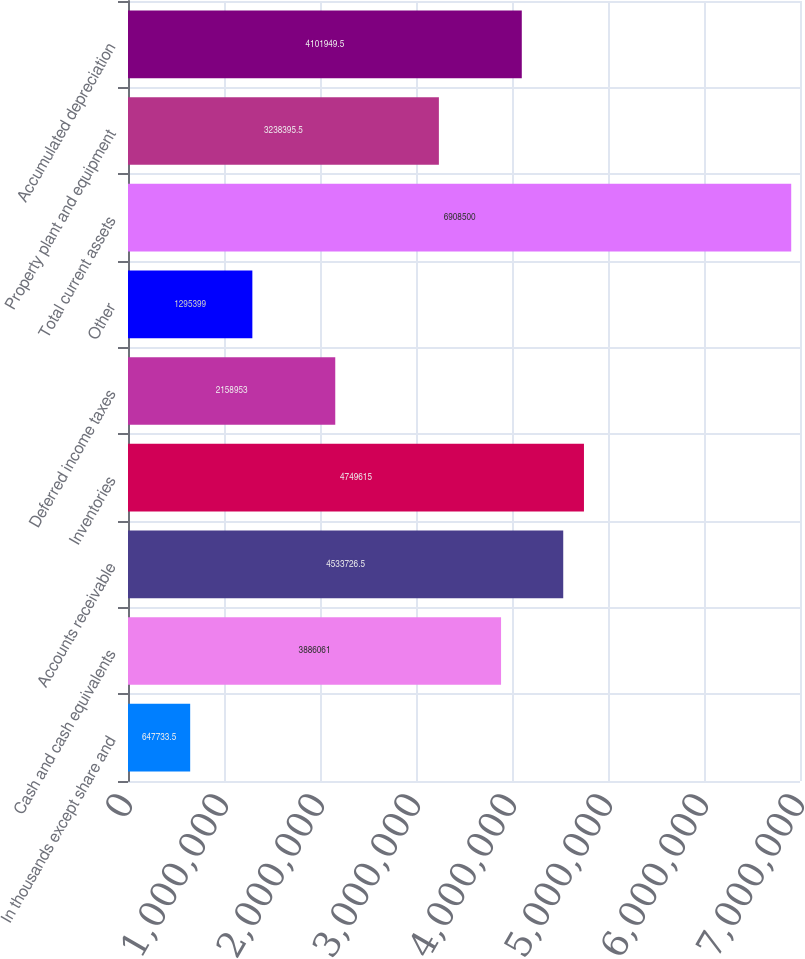Convert chart to OTSL. <chart><loc_0><loc_0><loc_500><loc_500><bar_chart><fcel>In thousands except share and<fcel>Cash and cash equivalents<fcel>Accounts receivable<fcel>Inventories<fcel>Deferred income taxes<fcel>Other<fcel>Total current assets<fcel>Property plant and equipment<fcel>Accumulated depreciation<nl><fcel>647734<fcel>3.88606e+06<fcel>4.53373e+06<fcel>4.74962e+06<fcel>2.15895e+06<fcel>1.2954e+06<fcel>6.9085e+06<fcel>3.2384e+06<fcel>4.10195e+06<nl></chart> 